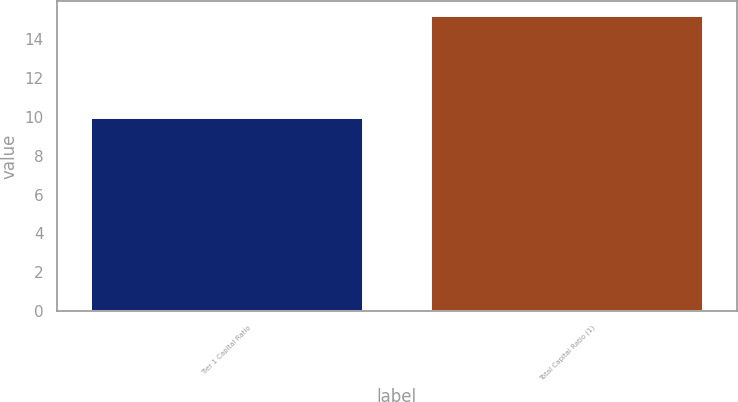Convert chart to OTSL. <chart><loc_0><loc_0><loc_500><loc_500><bar_chart><fcel>Tier 1 Capital Ratio<fcel>Total Capital Ratio (1)<nl><fcel>9.94<fcel>15.18<nl></chart> 